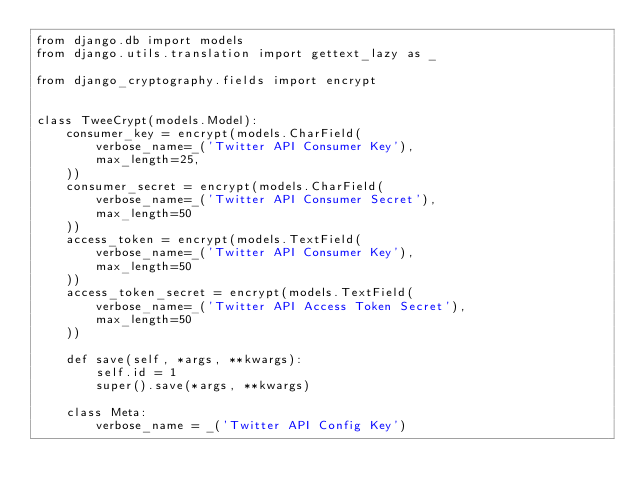<code> <loc_0><loc_0><loc_500><loc_500><_Python_>from django.db import modelsfrom django.utils.translation import gettext_lazy as _from django_cryptography.fields import encryptclass TweeCrypt(models.Model):    consumer_key = encrypt(models.CharField(        verbose_name=_('Twitter API Consumer Key'),        max_length=25,    ))    consumer_secret = encrypt(models.CharField(        verbose_name=_('Twitter API Consumer Secret'),        max_length=50    ))    access_token = encrypt(models.TextField(        verbose_name=_('Twitter API Consumer Key'),        max_length=50    ))    access_token_secret = encrypt(models.TextField(        verbose_name=_('Twitter API Access Token Secret'),        max_length=50    ))    def save(self, *args, **kwargs):        self.id = 1        super().save(*args, **kwargs)    class Meta:        verbose_name = _('Twitter API Config Key')</code> 